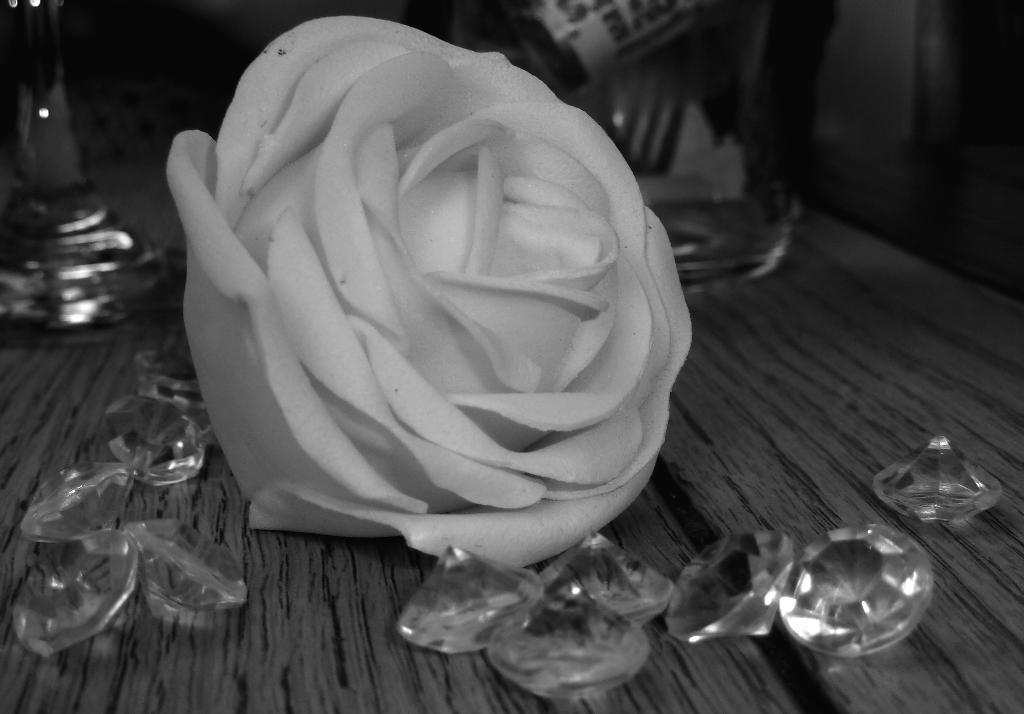In one or two sentences, can you explain what this image depicts? This is a wooden table where a white rose and diamonds are kept on it. 